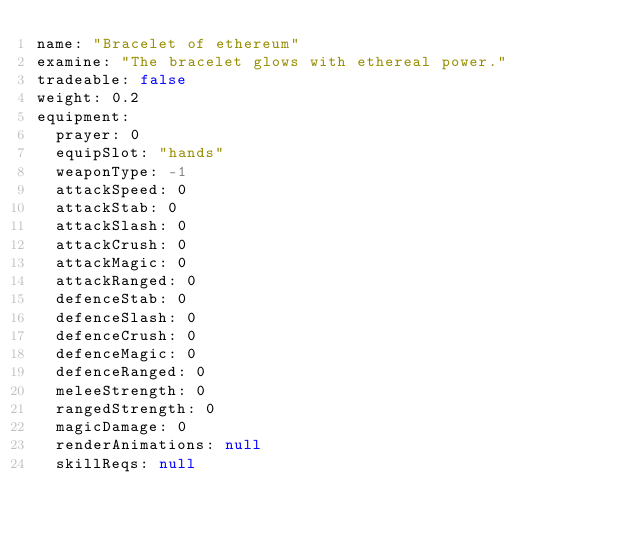Convert code to text. <code><loc_0><loc_0><loc_500><loc_500><_YAML_>name: "Bracelet of ethereum"
examine: "The bracelet glows with ethereal power."
tradeable: false
weight: 0.2
equipment:
  prayer: 0
  equipSlot: "hands"
  weaponType: -1
  attackSpeed: 0
  attackStab: 0
  attackSlash: 0
  attackCrush: 0
  attackMagic: 0
  attackRanged: 0
  defenceStab: 0
  defenceSlash: 0
  defenceCrush: 0
  defenceMagic: 0
  defenceRanged: 0
  meleeStrength: 0
  rangedStrength: 0
  magicDamage: 0
  renderAnimations: null
  skillReqs: null
</code> 